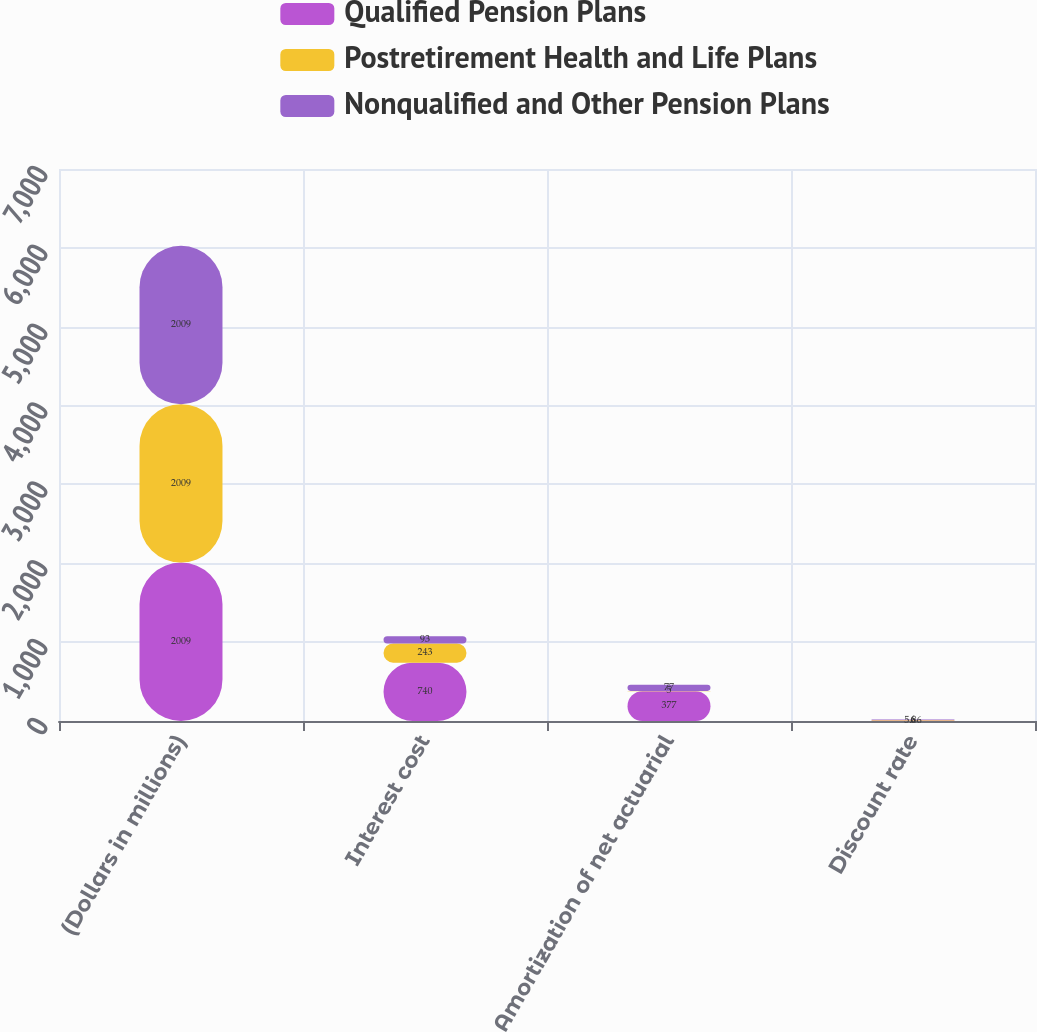Convert chart to OTSL. <chart><loc_0><loc_0><loc_500><loc_500><stacked_bar_chart><ecel><fcel>(Dollars in millions)<fcel>Interest cost<fcel>Amortization of net actuarial<fcel>Discount rate<nl><fcel>Qualified Pension Plans<fcel>2009<fcel>740<fcel>377<fcel>6<nl><fcel>Postretirement Health and Life Plans<fcel>2009<fcel>243<fcel>5<fcel>5.86<nl><fcel>Nonqualified and Other Pension Plans<fcel>2009<fcel>93<fcel>77<fcel>6<nl></chart> 